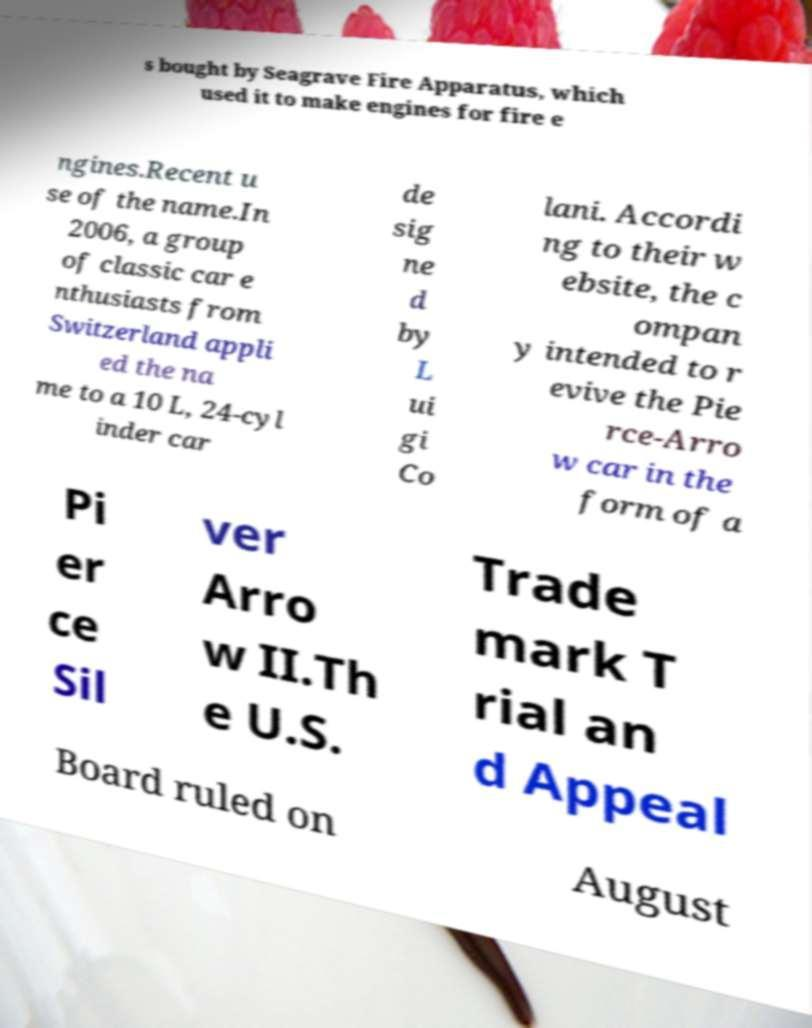Could you assist in decoding the text presented in this image and type it out clearly? s bought by Seagrave Fire Apparatus, which used it to make engines for fire e ngines.Recent u se of the name.In 2006, a group of classic car e nthusiasts from Switzerland appli ed the na me to a 10 L, 24-cyl inder car de sig ne d by L ui gi Co lani. Accordi ng to their w ebsite, the c ompan y intended to r evive the Pie rce-Arro w car in the form of a Pi er ce Sil ver Arro w II.Th e U.S. Trade mark T rial an d Appeal Board ruled on August 